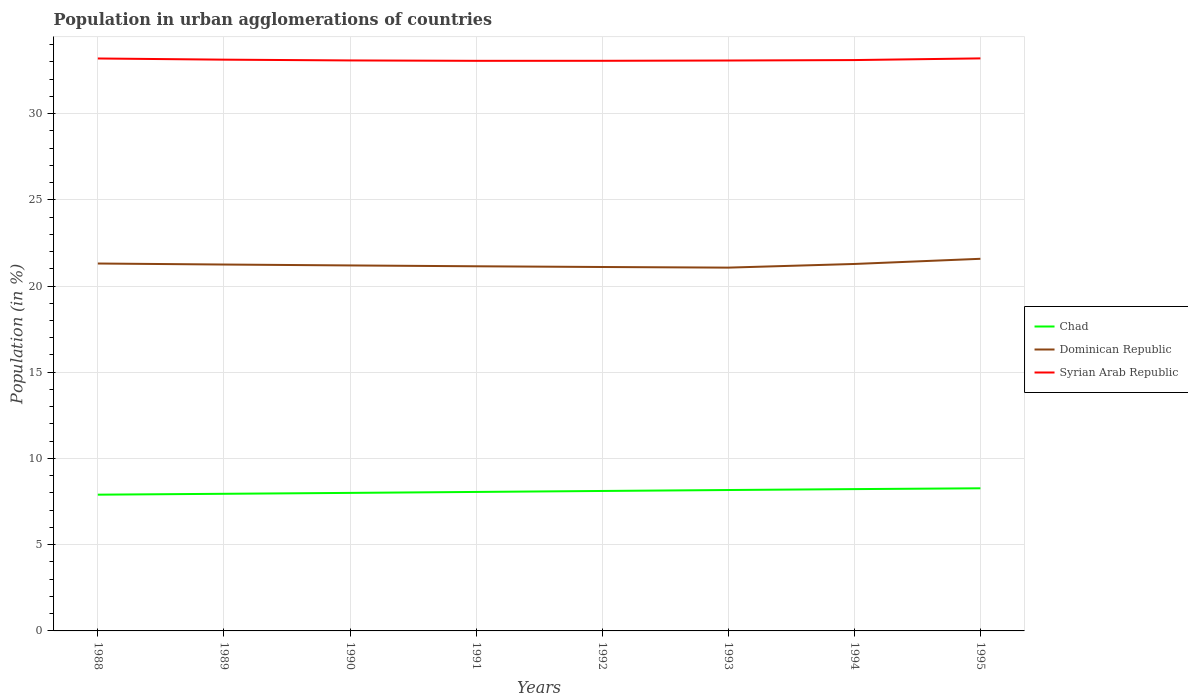Across all years, what is the maximum percentage of population in urban agglomerations in Syrian Arab Republic?
Provide a succinct answer. 33.06. What is the total percentage of population in urban agglomerations in Dominican Republic in the graph?
Your answer should be compact. -0.27. What is the difference between the highest and the second highest percentage of population in urban agglomerations in Chad?
Make the answer very short. 0.37. What is the difference between the highest and the lowest percentage of population in urban agglomerations in Dominican Republic?
Ensure brevity in your answer.  4. Is the percentage of population in urban agglomerations in Chad strictly greater than the percentage of population in urban agglomerations in Syrian Arab Republic over the years?
Give a very brief answer. Yes. How many years are there in the graph?
Ensure brevity in your answer.  8. What is the difference between two consecutive major ticks on the Y-axis?
Your answer should be compact. 5. Are the values on the major ticks of Y-axis written in scientific E-notation?
Give a very brief answer. No. Does the graph contain grids?
Offer a very short reply. Yes. How many legend labels are there?
Give a very brief answer. 3. What is the title of the graph?
Offer a very short reply. Population in urban agglomerations of countries. Does "Hungary" appear as one of the legend labels in the graph?
Your response must be concise. No. What is the label or title of the X-axis?
Offer a terse response. Years. What is the Population (in %) in Chad in 1988?
Offer a very short reply. 7.9. What is the Population (in %) of Dominican Republic in 1988?
Offer a very short reply. 21.3. What is the Population (in %) in Syrian Arab Republic in 1988?
Your answer should be compact. 33.19. What is the Population (in %) in Chad in 1989?
Provide a succinct answer. 7.95. What is the Population (in %) of Dominican Republic in 1989?
Give a very brief answer. 21.25. What is the Population (in %) of Syrian Arab Republic in 1989?
Your response must be concise. 33.13. What is the Population (in %) of Chad in 1990?
Your response must be concise. 8. What is the Population (in %) in Dominican Republic in 1990?
Your answer should be very brief. 21.19. What is the Population (in %) of Syrian Arab Republic in 1990?
Keep it short and to the point. 33.08. What is the Population (in %) of Chad in 1991?
Keep it short and to the point. 8.06. What is the Population (in %) of Dominican Republic in 1991?
Ensure brevity in your answer.  21.14. What is the Population (in %) of Syrian Arab Republic in 1991?
Make the answer very short. 33.06. What is the Population (in %) of Chad in 1992?
Make the answer very short. 8.12. What is the Population (in %) in Dominican Republic in 1992?
Offer a terse response. 21.1. What is the Population (in %) in Syrian Arab Republic in 1992?
Provide a succinct answer. 33.06. What is the Population (in %) of Chad in 1993?
Provide a short and direct response. 8.17. What is the Population (in %) of Dominican Republic in 1993?
Your answer should be very brief. 21.07. What is the Population (in %) of Syrian Arab Republic in 1993?
Give a very brief answer. 33.08. What is the Population (in %) in Chad in 1994?
Your answer should be very brief. 8.22. What is the Population (in %) in Dominican Republic in 1994?
Provide a succinct answer. 21.28. What is the Population (in %) of Syrian Arab Republic in 1994?
Your answer should be compact. 33.1. What is the Population (in %) of Chad in 1995?
Offer a terse response. 8.27. What is the Population (in %) of Dominican Republic in 1995?
Provide a short and direct response. 21.58. What is the Population (in %) in Syrian Arab Republic in 1995?
Offer a terse response. 33.2. Across all years, what is the maximum Population (in %) of Chad?
Your answer should be compact. 8.27. Across all years, what is the maximum Population (in %) in Dominican Republic?
Provide a succinct answer. 21.58. Across all years, what is the maximum Population (in %) in Syrian Arab Republic?
Ensure brevity in your answer.  33.2. Across all years, what is the minimum Population (in %) of Chad?
Your answer should be compact. 7.9. Across all years, what is the minimum Population (in %) in Dominican Republic?
Provide a succinct answer. 21.07. Across all years, what is the minimum Population (in %) of Syrian Arab Republic?
Make the answer very short. 33.06. What is the total Population (in %) of Chad in the graph?
Provide a succinct answer. 64.7. What is the total Population (in %) in Dominican Republic in the graph?
Provide a short and direct response. 169.91. What is the total Population (in %) in Syrian Arab Republic in the graph?
Keep it short and to the point. 264.9. What is the difference between the Population (in %) in Chad in 1988 and that in 1989?
Provide a short and direct response. -0.05. What is the difference between the Population (in %) of Dominican Republic in 1988 and that in 1989?
Your response must be concise. 0.06. What is the difference between the Population (in %) in Syrian Arab Republic in 1988 and that in 1989?
Your answer should be very brief. 0.07. What is the difference between the Population (in %) of Chad in 1988 and that in 1990?
Keep it short and to the point. -0.1. What is the difference between the Population (in %) in Dominican Republic in 1988 and that in 1990?
Your answer should be very brief. 0.11. What is the difference between the Population (in %) in Syrian Arab Republic in 1988 and that in 1990?
Offer a terse response. 0.11. What is the difference between the Population (in %) of Chad in 1988 and that in 1991?
Make the answer very short. -0.16. What is the difference between the Population (in %) of Dominican Republic in 1988 and that in 1991?
Ensure brevity in your answer.  0.16. What is the difference between the Population (in %) in Syrian Arab Republic in 1988 and that in 1991?
Keep it short and to the point. 0.14. What is the difference between the Population (in %) in Chad in 1988 and that in 1992?
Keep it short and to the point. -0.21. What is the difference between the Population (in %) of Dominican Republic in 1988 and that in 1992?
Your response must be concise. 0.2. What is the difference between the Population (in %) of Syrian Arab Republic in 1988 and that in 1992?
Offer a very short reply. 0.13. What is the difference between the Population (in %) in Chad in 1988 and that in 1993?
Your answer should be very brief. -0.27. What is the difference between the Population (in %) of Dominican Republic in 1988 and that in 1993?
Your response must be concise. 0.24. What is the difference between the Population (in %) of Syrian Arab Republic in 1988 and that in 1993?
Make the answer very short. 0.12. What is the difference between the Population (in %) in Chad in 1988 and that in 1994?
Your answer should be compact. -0.32. What is the difference between the Population (in %) of Dominican Republic in 1988 and that in 1994?
Provide a succinct answer. 0.03. What is the difference between the Population (in %) of Syrian Arab Republic in 1988 and that in 1994?
Keep it short and to the point. 0.09. What is the difference between the Population (in %) of Chad in 1988 and that in 1995?
Your answer should be very brief. -0.37. What is the difference between the Population (in %) of Dominican Republic in 1988 and that in 1995?
Ensure brevity in your answer.  -0.27. What is the difference between the Population (in %) in Syrian Arab Republic in 1988 and that in 1995?
Provide a succinct answer. -0.01. What is the difference between the Population (in %) in Chad in 1989 and that in 1990?
Keep it short and to the point. -0.05. What is the difference between the Population (in %) in Dominican Republic in 1989 and that in 1990?
Keep it short and to the point. 0.05. What is the difference between the Population (in %) of Syrian Arab Republic in 1989 and that in 1990?
Provide a succinct answer. 0.05. What is the difference between the Population (in %) in Chad in 1989 and that in 1991?
Your answer should be very brief. -0.11. What is the difference between the Population (in %) in Dominican Republic in 1989 and that in 1991?
Provide a succinct answer. 0.1. What is the difference between the Population (in %) of Syrian Arab Republic in 1989 and that in 1991?
Your answer should be compact. 0.07. What is the difference between the Population (in %) in Chad in 1989 and that in 1992?
Your answer should be compact. -0.16. What is the difference between the Population (in %) of Dominican Republic in 1989 and that in 1992?
Keep it short and to the point. 0.14. What is the difference between the Population (in %) in Syrian Arab Republic in 1989 and that in 1992?
Ensure brevity in your answer.  0.07. What is the difference between the Population (in %) of Chad in 1989 and that in 1993?
Provide a short and direct response. -0.22. What is the difference between the Population (in %) in Dominican Republic in 1989 and that in 1993?
Your answer should be compact. 0.18. What is the difference between the Population (in %) of Syrian Arab Republic in 1989 and that in 1993?
Provide a succinct answer. 0.05. What is the difference between the Population (in %) of Chad in 1989 and that in 1994?
Offer a very short reply. -0.27. What is the difference between the Population (in %) of Dominican Republic in 1989 and that in 1994?
Give a very brief answer. -0.03. What is the difference between the Population (in %) in Syrian Arab Republic in 1989 and that in 1994?
Make the answer very short. 0.02. What is the difference between the Population (in %) of Chad in 1989 and that in 1995?
Your response must be concise. -0.32. What is the difference between the Population (in %) of Dominican Republic in 1989 and that in 1995?
Keep it short and to the point. -0.33. What is the difference between the Population (in %) in Syrian Arab Republic in 1989 and that in 1995?
Your response must be concise. -0.07. What is the difference between the Population (in %) in Chad in 1990 and that in 1991?
Keep it short and to the point. -0.06. What is the difference between the Population (in %) in Dominican Republic in 1990 and that in 1991?
Provide a succinct answer. 0.05. What is the difference between the Population (in %) of Syrian Arab Republic in 1990 and that in 1991?
Provide a short and direct response. 0.02. What is the difference between the Population (in %) in Chad in 1990 and that in 1992?
Ensure brevity in your answer.  -0.11. What is the difference between the Population (in %) of Dominican Republic in 1990 and that in 1992?
Your answer should be compact. 0.09. What is the difference between the Population (in %) in Syrian Arab Republic in 1990 and that in 1992?
Offer a very short reply. 0.02. What is the difference between the Population (in %) of Chad in 1990 and that in 1993?
Your answer should be compact. -0.17. What is the difference between the Population (in %) of Dominican Republic in 1990 and that in 1993?
Provide a short and direct response. 0.13. What is the difference between the Population (in %) of Syrian Arab Republic in 1990 and that in 1993?
Offer a very short reply. 0.01. What is the difference between the Population (in %) in Chad in 1990 and that in 1994?
Provide a short and direct response. -0.22. What is the difference between the Population (in %) in Dominican Republic in 1990 and that in 1994?
Provide a short and direct response. -0.09. What is the difference between the Population (in %) of Syrian Arab Republic in 1990 and that in 1994?
Provide a succinct answer. -0.02. What is the difference between the Population (in %) in Chad in 1990 and that in 1995?
Your answer should be compact. -0.27. What is the difference between the Population (in %) in Dominican Republic in 1990 and that in 1995?
Your response must be concise. -0.39. What is the difference between the Population (in %) in Syrian Arab Republic in 1990 and that in 1995?
Keep it short and to the point. -0.12. What is the difference between the Population (in %) of Chad in 1991 and that in 1992?
Make the answer very short. -0.06. What is the difference between the Population (in %) of Dominican Republic in 1991 and that in 1992?
Keep it short and to the point. 0.04. What is the difference between the Population (in %) in Syrian Arab Republic in 1991 and that in 1992?
Your answer should be compact. -0. What is the difference between the Population (in %) in Chad in 1991 and that in 1993?
Offer a very short reply. -0.11. What is the difference between the Population (in %) of Dominican Republic in 1991 and that in 1993?
Offer a terse response. 0.08. What is the difference between the Population (in %) of Syrian Arab Republic in 1991 and that in 1993?
Your answer should be very brief. -0.02. What is the difference between the Population (in %) of Chad in 1991 and that in 1994?
Your answer should be compact. -0.16. What is the difference between the Population (in %) in Dominican Republic in 1991 and that in 1994?
Provide a short and direct response. -0.13. What is the difference between the Population (in %) of Syrian Arab Republic in 1991 and that in 1994?
Provide a succinct answer. -0.04. What is the difference between the Population (in %) in Chad in 1991 and that in 1995?
Your answer should be compact. -0.21. What is the difference between the Population (in %) of Dominican Republic in 1991 and that in 1995?
Provide a short and direct response. -0.43. What is the difference between the Population (in %) in Syrian Arab Republic in 1991 and that in 1995?
Your response must be concise. -0.14. What is the difference between the Population (in %) of Chad in 1992 and that in 1993?
Provide a succinct answer. -0.06. What is the difference between the Population (in %) in Dominican Republic in 1992 and that in 1993?
Provide a succinct answer. 0.04. What is the difference between the Population (in %) in Syrian Arab Republic in 1992 and that in 1993?
Ensure brevity in your answer.  -0.02. What is the difference between the Population (in %) of Chad in 1992 and that in 1994?
Make the answer very short. -0.11. What is the difference between the Population (in %) in Dominican Republic in 1992 and that in 1994?
Offer a very short reply. -0.18. What is the difference between the Population (in %) in Syrian Arab Republic in 1992 and that in 1994?
Your answer should be very brief. -0.04. What is the difference between the Population (in %) in Chad in 1992 and that in 1995?
Give a very brief answer. -0.15. What is the difference between the Population (in %) of Dominican Republic in 1992 and that in 1995?
Keep it short and to the point. -0.48. What is the difference between the Population (in %) of Syrian Arab Republic in 1992 and that in 1995?
Offer a terse response. -0.14. What is the difference between the Population (in %) in Chad in 1993 and that in 1994?
Offer a very short reply. -0.05. What is the difference between the Population (in %) of Dominican Republic in 1993 and that in 1994?
Provide a succinct answer. -0.21. What is the difference between the Population (in %) of Syrian Arab Republic in 1993 and that in 1994?
Make the answer very short. -0.03. What is the difference between the Population (in %) in Chad in 1993 and that in 1995?
Keep it short and to the point. -0.1. What is the difference between the Population (in %) in Dominican Republic in 1993 and that in 1995?
Provide a short and direct response. -0.51. What is the difference between the Population (in %) in Syrian Arab Republic in 1993 and that in 1995?
Your response must be concise. -0.12. What is the difference between the Population (in %) of Chad in 1994 and that in 1995?
Keep it short and to the point. -0.05. What is the difference between the Population (in %) of Syrian Arab Republic in 1994 and that in 1995?
Ensure brevity in your answer.  -0.1. What is the difference between the Population (in %) of Chad in 1988 and the Population (in %) of Dominican Republic in 1989?
Make the answer very short. -13.34. What is the difference between the Population (in %) in Chad in 1988 and the Population (in %) in Syrian Arab Republic in 1989?
Your answer should be very brief. -25.23. What is the difference between the Population (in %) of Dominican Republic in 1988 and the Population (in %) of Syrian Arab Republic in 1989?
Your answer should be very brief. -11.82. What is the difference between the Population (in %) of Chad in 1988 and the Population (in %) of Dominican Republic in 1990?
Provide a succinct answer. -13.29. What is the difference between the Population (in %) of Chad in 1988 and the Population (in %) of Syrian Arab Republic in 1990?
Offer a very short reply. -25.18. What is the difference between the Population (in %) in Dominican Republic in 1988 and the Population (in %) in Syrian Arab Republic in 1990?
Ensure brevity in your answer.  -11.78. What is the difference between the Population (in %) of Chad in 1988 and the Population (in %) of Dominican Republic in 1991?
Offer a very short reply. -13.24. What is the difference between the Population (in %) of Chad in 1988 and the Population (in %) of Syrian Arab Republic in 1991?
Your answer should be very brief. -25.16. What is the difference between the Population (in %) in Dominican Republic in 1988 and the Population (in %) in Syrian Arab Republic in 1991?
Make the answer very short. -11.75. What is the difference between the Population (in %) of Chad in 1988 and the Population (in %) of Dominican Republic in 1992?
Make the answer very short. -13.2. What is the difference between the Population (in %) in Chad in 1988 and the Population (in %) in Syrian Arab Republic in 1992?
Offer a very short reply. -25.16. What is the difference between the Population (in %) of Dominican Republic in 1988 and the Population (in %) of Syrian Arab Republic in 1992?
Your answer should be very brief. -11.76. What is the difference between the Population (in %) of Chad in 1988 and the Population (in %) of Dominican Republic in 1993?
Provide a short and direct response. -13.17. What is the difference between the Population (in %) in Chad in 1988 and the Population (in %) in Syrian Arab Republic in 1993?
Your answer should be very brief. -25.17. What is the difference between the Population (in %) in Dominican Republic in 1988 and the Population (in %) in Syrian Arab Republic in 1993?
Give a very brief answer. -11.77. What is the difference between the Population (in %) in Chad in 1988 and the Population (in %) in Dominican Republic in 1994?
Offer a terse response. -13.38. What is the difference between the Population (in %) in Chad in 1988 and the Population (in %) in Syrian Arab Republic in 1994?
Provide a succinct answer. -25.2. What is the difference between the Population (in %) in Dominican Republic in 1988 and the Population (in %) in Syrian Arab Republic in 1994?
Ensure brevity in your answer.  -11.8. What is the difference between the Population (in %) of Chad in 1988 and the Population (in %) of Dominican Republic in 1995?
Ensure brevity in your answer.  -13.68. What is the difference between the Population (in %) in Chad in 1988 and the Population (in %) in Syrian Arab Republic in 1995?
Give a very brief answer. -25.3. What is the difference between the Population (in %) of Dominican Republic in 1988 and the Population (in %) of Syrian Arab Republic in 1995?
Give a very brief answer. -11.9. What is the difference between the Population (in %) in Chad in 1989 and the Population (in %) in Dominican Republic in 1990?
Your response must be concise. -13.24. What is the difference between the Population (in %) in Chad in 1989 and the Population (in %) in Syrian Arab Republic in 1990?
Provide a succinct answer. -25.13. What is the difference between the Population (in %) in Dominican Republic in 1989 and the Population (in %) in Syrian Arab Republic in 1990?
Your answer should be compact. -11.84. What is the difference between the Population (in %) in Chad in 1989 and the Population (in %) in Dominican Republic in 1991?
Ensure brevity in your answer.  -13.19. What is the difference between the Population (in %) of Chad in 1989 and the Population (in %) of Syrian Arab Republic in 1991?
Your answer should be compact. -25.11. What is the difference between the Population (in %) of Dominican Republic in 1989 and the Population (in %) of Syrian Arab Republic in 1991?
Your answer should be very brief. -11.81. What is the difference between the Population (in %) in Chad in 1989 and the Population (in %) in Dominican Republic in 1992?
Give a very brief answer. -13.15. What is the difference between the Population (in %) in Chad in 1989 and the Population (in %) in Syrian Arab Republic in 1992?
Keep it short and to the point. -25.11. What is the difference between the Population (in %) of Dominican Republic in 1989 and the Population (in %) of Syrian Arab Republic in 1992?
Your response must be concise. -11.81. What is the difference between the Population (in %) in Chad in 1989 and the Population (in %) in Dominican Republic in 1993?
Give a very brief answer. -13.12. What is the difference between the Population (in %) in Chad in 1989 and the Population (in %) in Syrian Arab Republic in 1993?
Your answer should be compact. -25.12. What is the difference between the Population (in %) of Dominican Republic in 1989 and the Population (in %) of Syrian Arab Republic in 1993?
Offer a terse response. -11.83. What is the difference between the Population (in %) of Chad in 1989 and the Population (in %) of Dominican Republic in 1994?
Your response must be concise. -13.33. What is the difference between the Population (in %) of Chad in 1989 and the Population (in %) of Syrian Arab Republic in 1994?
Give a very brief answer. -25.15. What is the difference between the Population (in %) of Dominican Republic in 1989 and the Population (in %) of Syrian Arab Republic in 1994?
Give a very brief answer. -11.86. What is the difference between the Population (in %) of Chad in 1989 and the Population (in %) of Dominican Republic in 1995?
Provide a short and direct response. -13.63. What is the difference between the Population (in %) in Chad in 1989 and the Population (in %) in Syrian Arab Republic in 1995?
Your response must be concise. -25.25. What is the difference between the Population (in %) of Dominican Republic in 1989 and the Population (in %) of Syrian Arab Republic in 1995?
Provide a short and direct response. -11.95. What is the difference between the Population (in %) in Chad in 1990 and the Population (in %) in Dominican Republic in 1991?
Keep it short and to the point. -13.14. What is the difference between the Population (in %) in Chad in 1990 and the Population (in %) in Syrian Arab Republic in 1991?
Provide a succinct answer. -25.05. What is the difference between the Population (in %) in Dominican Republic in 1990 and the Population (in %) in Syrian Arab Republic in 1991?
Provide a short and direct response. -11.87. What is the difference between the Population (in %) of Chad in 1990 and the Population (in %) of Dominican Republic in 1992?
Your answer should be compact. -13.1. What is the difference between the Population (in %) in Chad in 1990 and the Population (in %) in Syrian Arab Republic in 1992?
Your response must be concise. -25.06. What is the difference between the Population (in %) in Dominican Republic in 1990 and the Population (in %) in Syrian Arab Republic in 1992?
Your answer should be compact. -11.87. What is the difference between the Population (in %) in Chad in 1990 and the Population (in %) in Dominican Republic in 1993?
Provide a short and direct response. -13.06. What is the difference between the Population (in %) of Chad in 1990 and the Population (in %) of Syrian Arab Republic in 1993?
Your answer should be compact. -25.07. What is the difference between the Population (in %) of Dominican Republic in 1990 and the Population (in %) of Syrian Arab Republic in 1993?
Make the answer very short. -11.88. What is the difference between the Population (in %) in Chad in 1990 and the Population (in %) in Dominican Republic in 1994?
Offer a terse response. -13.27. What is the difference between the Population (in %) of Chad in 1990 and the Population (in %) of Syrian Arab Republic in 1994?
Offer a very short reply. -25.1. What is the difference between the Population (in %) of Dominican Republic in 1990 and the Population (in %) of Syrian Arab Republic in 1994?
Your answer should be compact. -11.91. What is the difference between the Population (in %) in Chad in 1990 and the Population (in %) in Dominican Republic in 1995?
Your answer should be compact. -13.57. What is the difference between the Population (in %) of Chad in 1990 and the Population (in %) of Syrian Arab Republic in 1995?
Ensure brevity in your answer.  -25.2. What is the difference between the Population (in %) of Dominican Republic in 1990 and the Population (in %) of Syrian Arab Republic in 1995?
Your answer should be very brief. -12.01. What is the difference between the Population (in %) of Chad in 1991 and the Population (in %) of Dominican Republic in 1992?
Offer a very short reply. -13.04. What is the difference between the Population (in %) of Chad in 1991 and the Population (in %) of Syrian Arab Republic in 1992?
Your answer should be compact. -25. What is the difference between the Population (in %) in Dominican Republic in 1991 and the Population (in %) in Syrian Arab Republic in 1992?
Provide a short and direct response. -11.92. What is the difference between the Population (in %) in Chad in 1991 and the Population (in %) in Dominican Republic in 1993?
Provide a succinct answer. -13.01. What is the difference between the Population (in %) of Chad in 1991 and the Population (in %) of Syrian Arab Republic in 1993?
Provide a short and direct response. -25.02. What is the difference between the Population (in %) of Dominican Republic in 1991 and the Population (in %) of Syrian Arab Republic in 1993?
Your answer should be very brief. -11.93. What is the difference between the Population (in %) in Chad in 1991 and the Population (in %) in Dominican Republic in 1994?
Make the answer very short. -13.22. What is the difference between the Population (in %) of Chad in 1991 and the Population (in %) of Syrian Arab Republic in 1994?
Provide a succinct answer. -25.04. What is the difference between the Population (in %) in Dominican Republic in 1991 and the Population (in %) in Syrian Arab Republic in 1994?
Ensure brevity in your answer.  -11.96. What is the difference between the Population (in %) in Chad in 1991 and the Population (in %) in Dominican Republic in 1995?
Your answer should be very brief. -13.52. What is the difference between the Population (in %) of Chad in 1991 and the Population (in %) of Syrian Arab Republic in 1995?
Your answer should be very brief. -25.14. What is the difference between the Population (in %) of Dominican Republic in 1991 and the Population (in %) of Syrian Arab Republic in 1995?
Provide a succinct answer. -12.05. What is the difference between the Population (in %) in Chad in 1992 and the Population (in %) in Dominican Republic in 1993?
Ensure brevity in your answer.  -12.95. What is the difference between the Population (in %) in Chad in 1992 and the Population (in %) in Syrian Arab Republic in 1993?
Give a very brief answer. -24.96. What is the difference between the Population (in %) in Dominican Republic in 1992 and the Population (in %) in Syrian Arab Republic in 1993?
Provide a succinct answer. -11.97. What is the difference between the Population (in %) in Chad in 1992 and the Population (in %) in Dominican Republic in 1994?
Keep it short and to the point. -13.16. What is the difference between the Population (in %) of Chad in 1992 and the Population (in %) of Syrian Arab Republic in 1994?
Offer a very short reply. -24.99. What is the difference between the Population (in %) in Dominican Republic in 1992 and the Population (in %) in Syrian Arab Republic in 1994?
Your answer should be compact. -12. What is the difference between the Population (in %) of Chad in 1992 and the Population (in %) of Dominican Republic in 1995?
Your answer should be very brief. -13.46. What is the difference between the Population (in %) of Chad in 1992 and the Population (in %) of Syrian Arab Republic in 1995?
Provide a short and direct response. -25.08. What is the difference between the Population (in %) of Dominican Republic in 1992 and the Population (in %) of Syrian Arab Republic in 1995?
Provide a short and direct response. -12.1. What is the difference between the Population (in %) in Chad in 1993 and the Population (in %) in Dominican Republic in 1994?
Your answer should be compact. -13.11. What is the difference between the Population (in %) in Chad in 1993 and the Population (in %) in Syrian Arab Republic in 1994?
Make the answer very short. -24.93. What is the difference between the Population (in %) of Dominican Republic in 1993 and the Population (in %) of Syrian Arab Republic in 1994?
Make the answer very short. -12.04. What is the difference between the Population (in %) in Chad in 1993 and the Population (in %) in Dominican Republic in 1995?
Make the answer very short. -13.41. What is the difference between the Population (in %) in Chad in 1993 and the Population (in %) in Syrian Arab Republic in 1995?
Give a very brief answer. -25.03. What is the difference between the Population (in %) of Dominican Republic in 1993 and the Population (in %) of Syrian Arab Republic in 1995?
Provide a succinct answer. -12.13. What is the difference between the Population (in %) of Chad in 1994 and the Population (in %) of Dominican Republic in 1995?
Offer a terse response. -13.36. What is the difference between the Population (in %) of Chad in 1994 and the Population (in %) of Syrian Arab Republic in 1995?
Your answer should be very brief. -24.98. What is the difference between the Population (in %) of Dominican Republic in 1994 and the Population (in %) of Syrian Arab Republic in 1995?
Give a very brief answer. -11.92. What is the average Population (in %) in Chad per year?
Keep it short and to the point. 8.09. What is the average Population (in %) of Dominican Republic per year?
Your response must be concise. 21.24. What is the average Population (in %) in Syrian Arab Republic per year?
Offer a terse response. 33.11. In the year 1988, what is the difference between the Population (in %) of Chad and Population (in %) of Dominican Republic?
Make the answer very short. -13.4. In the year 1988, what is the difference between the Population (in %) of Chad and Population (in %) of Syrian Arab Republic?
Ensure brevity in your answer.  -25.29. In the year 1988, what is the difference between the Population (in %) in Dominican Republic and Population (in %) in Syrian Arab Republic?
Provide a succinct answer. -11.89. In the year 1989, what is the difference between the Population (in %) of Chad and Population (in %) of Dominican Republic?
Make the answer very short. -13.29. In the year 1989, what is the difference between the Population (in %) in Chad and Population (in %) in Syrian Arab Republic?
Ensure brevity in your answer.  -25.18. In the year 1989, what is the difference between the Population (in %) of Dominican Republic and Population (in %) of Syrian Arab Republic?
Provide a succinct answer. -11.88. In the year 1990, what is the difference between the Population (in %) in Chad and Population (in %) in Dominican Republic?
Offer a terse response. -13.19. In the year 1990, what is the difference between the Population (in %) of Chad and Population (in %) of Syrian Arab Republic?
Keep it short and to the point. -25.08. In the year 1990, what is the difference between the Population (in %) in Dominican Republic and Population (in %) in Syrian Arab Republic?
Give a very brief answer. -11.89. In the year 1991, what is the difference between the Population (in %) in Chad and Population (in %) in Dominican Republic?
Ensure brevity in your answer.  -13.09. In the year 1991, what is the difference between the Population (in %) of Chad and Population (in %) of Syrian Arab Republic?
Make the answer very short. -25. In the year 1991, what is the difference between the Population (in %) in Dominican Republic and Population (in %) in Syrian Arab Republic?
Give a very brief answer. -11.91. In the year 1992, what is the difference between the Population (in %) in Chad and Population (in %) in Dominican Republic?
Offer a very short reply. -12.99. In the year 1992, what is the difference between the Population (in %) in Chad and Population (in %) in Syrian Arab Republic?
Ensure brevity in your answer.  -24.94. In the year 1992, what is the difference between the Population (in %) of Dominican Republic and Population (in %) of Syrian Arab Republic?
Keep it short and to the point. -11.96. In the year 1993, what is the difference between the Population (in %) in Chad and Population (in %) in Dominican Republic?
Make the answer very short. -12.9. In the year 1993, what is the difference between the Population (in %) in Chad and Population (in %) in Syrian Arab Republic?
Provide a succinct answer. -24.91. In the year 1993, what is the difference between the Population (in %) in Dominican Republic and Population (in %) in Syrian Arab Republic?
Make the answer very short. -12.01. In the year 1994, what is the difference between the Population (in %) in Chad and Population (in %) in Dominican Republic?
Offer a very short reply. -13.06. In the year 1994, what is the difference between the Population (in %) in Chad and Population (in %) in Syrian Arab Republic?
Your answer should be very brief. -24.88. In the year 1994, what is the difference between the Population (in %) of Dominican Republic and Population (in %) of Syrian Arab Republic?
Ensure brevity in your answer.  -11.82. In the year 1995, what is the difference between the Population (in %) of Chad and Population (in %) of Dominican Republic?
Provide a short and direct response. -13.31. In the year 1995, what is the difference between the Population (in %) in Chad and Population (in %) in Syrian Arab Republic?
Give a very brief answer. -24.93. In the year 1995, what is the difference between the Population (in %) in Dominican Republic and Population (in %) in Syrian Arab Republic?
Give a very brief answer. -11.62. What is the ratio of the Population (in %) in Dominican Republic in 1988 to that in 1989?
Ensure brevity in your answer.  1. What is the ratio of the Population (in %) of Syrian Arab Republic in 1988 to that in 1989?
Your answer should be very brief. 1. What is the ratio of the Population (in %) in Chad in 1988 to that in 1990?
Provide a succinct answer. 0.99. What is the ratio of the Population (in %) in Syrian Arab Republic in 1988 to that in 1990?
Ensure brevity in your answer.  1. What is the ratio of the Population (in %) in Chad in 1988 to that in 1991?
Give a very brief answer. 0.98. What is the ratio of the Population (in %) in Dominican Republic in 1988 to that in 1991?
Ensure brevity in your answer.  1.01. What is the ratio of the Population (in %) of Chad in 1988 to that in 1992?
Your response must be concise. 0.97. What is the ratio of the Population (in %) in Dominican Republic in 1988 to that in 1992?
Keep it short and to the point. 1.01. What is the ratio of the Population (in %) of Syrian Arab Republic in 1988 to that in 1992?
Provide a succinct answer. 1. What is the ratio of the Population (in %) of Chad in 1988 to that in 1993?
Provide a succinct answer. 0.97. What is the ratio of the Population (in %) of Dominican Republic in 1988 to that in 1993?
Give a very brief answer. 1.01. What is the ratio of the Population (in %) of Syrian Arab Republic in 1988 to that in 1993?
Make the answer very short. 1. What is the ratio of the Population (in %) in Chad in 1988 to that in 1994?
Your answer should be very brief. 0.96. What is the ratio of the Population (in %) in Chad in 1988 to that in 1995?
Keep it short and to the point. 0.96. What is the ratio of the Population (in %) of Dominican Republic in 1988 to that in 1995?
Your response must be concise. 0.99. What is the ratio of the Population (in %) in Syrian Arab Republic in 1988 to that in 1995?
Offer a terse response. 1. What is the ratio of the Population (in %) of Chad in 1989 to that in 1991?
Your answer should be very brief. 0.99. What is the ratio of the Population (in %) in Chad in 1989 to that in 1992?
Offer a very short reply. 0.98. What is the ratio of the Population (in %) in Dominican Republic in 1989 to that in 1992?
Make the answer very short. 1.01. What is the ratio of the Population (in %) of Chad in 1989 to that in 1993?
Make the answer very short. 0.97. What is the ratio of the Population (in %) in Dominican Republic in 1989 to that in 1993?
Provide a succinct answer. 1.01. What is the ratio of the Population (in %) of Syrian Arab Republic in 1989 to that in 1993?
Your response must be concise. 1. What is the ratio of the Population (in %) of Chad in 1989 to that in 1994?
Provide a succinct answer. 0.97. What is the ratio of the Population (in %) of Chad in 1989 to that in 1995?
Ensure brevity in your answer.  0.96. What is the ratio of the Population (in %) of Dominican Republic in 1989 to that in 1995?
Make the answer very short. 0.98. What is the ratio of the Population (in %) in Chad in 1990 to that in 1991?
Offer a very short reply. 0.99. What is the ratio of the Population (in %) in Dominican Republic in 1990 to that in 1991?
Your answer should be compact. 1. What is the ratio of the Population (in %) in Syrian Arab Republic in 1990 to that in 1991?
Give a very brief answer. 1. What is the ratio of the Population (in %) in Chad in 1990 to that in 1992?
Make the answer very short. 0.99. What is the ratio of the Population (in %) in Dominican Republic in 1990 to that in 1992?
Offer a very short reply. 1. What is the ratio of the Population (in %) in Syrian Arab Republic in 1990 to that in 1992?
Make the answer very short. 1. What is the ratio of the Population (in %) in Chad in 1990 to that in 1993?
Your response must be concise. 0.98. What is the ratio of the Population (in %) in Dominican Republic in 1990 to that in 1993?
Your answer should be very brief. 1.01. What is the ratio of the Population (in %) of Syrian Arab Republic in 1990 to that in 1993?
Offer a very short reply. 1. What is the ratio of the Population (in %) of Chad in 1990 to that in 1994?
Offer a very short reply. 0.97. What is the ratio of the Population (in %) of Dominican Republic in 1990 to that in 1994?
Your response must be concise. 1. What is the ratio of the Population (in %) in Chad in 1990 to that in 1995?
Ensure brevity in your answer.  0.97. What is the ratio of the Population (in %) in Dominican Republic in 1990 to that in 1995?
Make the answer very short. 0.98. What is the ratio of the Population (in %) in Chad in 1991 to that in 1992?
Ensure brevity in your answer.  0.99. What is the ratio of the Population (in %) of Dominican Republic in 1991 to that in 1992?
Give a very brief answer. 1. What is the ratio of the Population (in %) of Chad in 1991 to that in 1993?
Offer a terse response. 0.99. What is the ratio of the Population (in %) in Dominican Republic in 1991 to that in 1993?
Make the answer very short. 1. What is the ratio of the Population (in %) of Syrian Arab Republic in 1991 to that in 1993?
Your answer should be compact. 1. What is the ratio of the Population (in %) in Chad in 1991 to that in 1994?
Ensure brevity in your answer.  0.98. What is the ratio of the Population (in %) in Syrian Arab Republic in 1991 to that in 1994?
Offer a terse response. 1. What is the ratio of the Population (in %) in Chad in 1991 to that in 1995?
Provide a short and direct response. 0.97. What is the ratio of the Population (in %) of Dominican Republic in 1991 to that in 1995?
Offer a very short reply. 0.98. What is the ratio of the Population (in %) of Syrian Arab Republic in 1991 to that in 1995?
Offer a very short reply. 1. What is the ratio of the Population (in %) in Chad in 1992 to that in 1994?
Your answer should be compact. 0.99. What is the ratio of the Population (in %) of Dominican Republic in 1992 to that in 1994?
Provide a succinct answer. 0.99. What is the ratio of the Population (in %) in Chad in 1992 to that in 1995?
Your response must be concise. 0.98. What is the ratio of the Population (in %) in Dominican Republic in 1992 to that in 1995?
Your response must be concise. 0.98. What is the ratio of the Population (in %) in Syrian Arab Republic in 1992 to that in 1995?
Offer a terse response. 1. What is the ratio of the Population (in %) in Chad in 1993 to that in 1994?
Keep it short and to the point. 0.99. What is the ratio of the Population (in %) of Dominican Republic in 1993 to that in 1994?
Make the answer very short. 0.99. What is the ratio of the Population (in %) in Syrian Arab Republic in 1993 to that in 1994?
Make the answer very short. 1. What is the ratio of the Population (in %) in Dominican Republic in 1993 to that in 1995?
Your response must be concise. 0.98. What is the ratio of the Population (in %) of Syrian Arab Republic in 1993 to that in 1995?
Offer a very short reply. 1. What is the ratio of the Population (in %) in Chad in 1994 to that in 1995?
Your answer should be very brief. 0.99. What is the ratio of the Population (in %) in Dominican Republic in 1994 to that in 1995?
Offer a very short reply. 0.99. What is the ratio of the Population (in %) of Syrian Arab Republic in 1994 to that in 1995?
Offer a very short reply. 1. What is the difference between the highest and the second highest Population (in %) in Chad?
Your answer should be very brief. 0.05. What is the difference between the highest and the second highest Population (in %) in Dominican Republic?
Keep it short and to the point. 0.27. What is the difference between the highest and the second highest Population (in %) of Syrian Arab Republic?
Provide a succinct answer. 0.01. What is the difference between the highest and the lowest Population (in %) of Chad?
Provide a short and direct response. 0.37. What is the difference between the highest and the lowest Population (in %) of Dominican Republic?
Offer a terse response. 0.51. What is the difference between the highest and the lowest Population (in %) in Syrian Arab Republic?
Offer a very short reply. 0.14. 